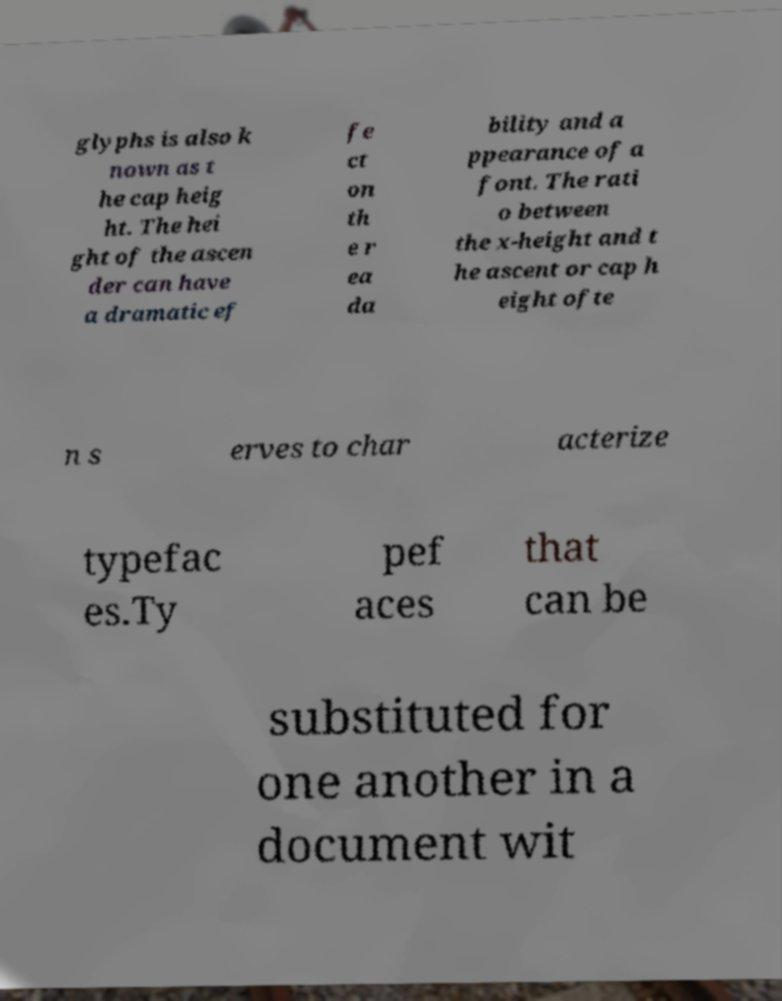For documentation purposes, I need the text within this image transcribed. Could you provide that? glyphs is also k nown as t he cap heig ht. The hei ght of the ascen der can have a dramatic ef fe ct on th e r ea da bility and a ppearance of a font. The rati o between the x-height and t he ascent or cap h eight ofte n s erves to char acterize typefac es.Ty pef aces that can be substituted for one another in a document wit 